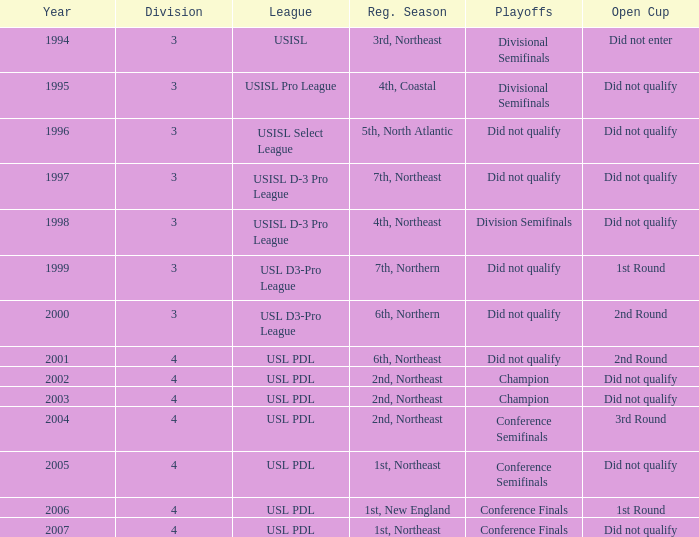Name the total number of years for usisl pro league 1.0. 